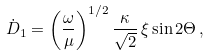Convert formula to latex. <formula><loc_0><loc_0><loc_500><loc_500>\dot { D } _ { 1 } = \left ( \frac { \omega } { \mu } \right ) ^ { 1 / 2 } \frac { \kappa } { \sqrt { 2 } } \, \xi \sin 2 \Theta \, ,</formula> 